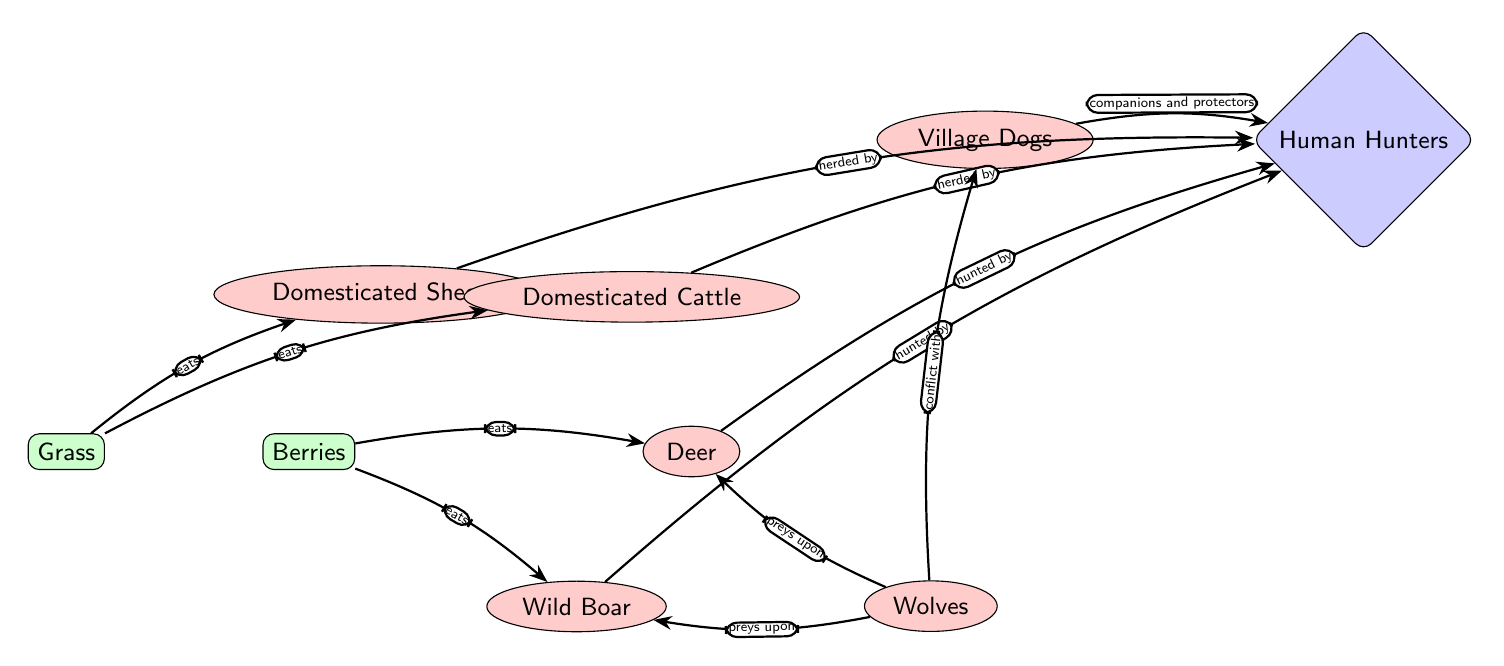What is the primary prey for domesticated sheep? The diagram indicates that domesticated sheep eat grass, as represented by the edge labeled "eats" from grass to sheep.
Answer: Grass How many types of predators are shown in the diagram? Counting the nodes labeled as predators, we find sheep, wild boar, domesticated cattle, deer, village dogs, and wolves. This totals six distinct predator types.
Answer: Six Which animal is primarily hunted by humans in the diagram? The diagram highlights deer and wild boar as prey hunted by humans, indicated by the edge labeled "hunted by" from deer and boar to humans.
Answer: Deer and wild boar What relationship do wolves have with deer according to the diagram? The edges labeled "preys upon" indicate that wolves prey on deer, showing a direct predator-prey relationship.
Answer: Preys upon Which domesticated animal is shown to be herded by humans? The diagram illustrates that both domesticated sheep and domesticated cattle are herded by humans, as indicated by the edges labeled "herded by."
Answer: Domesticated sheep and cattle How do dogs interact with humans in the ecosystem illustrated? The diagram indicates that dogs serve as companions and protectors for humans, marking their role in the human-animal relationship.
Answer: Companions and protectors What do wild boar primarily consume according to the food chain? The diagram shows an edge labeled "eats," pointing from berries to wild boar, indicating that wild boar primarily consume berries.
Answer: Berries What is the role of wolves in the ecosystem shown? The diagram shows that wolves are predators that prey upon both deer and wild boar, indicating their role as hunters within the food chain.
Answer: Predators How do the village dogs interact with wolves? The diagram shows an edge labeled "conflict with" indicating an adversarial relationship between village dogs and wolves, highlighting their competition in the ecosystem.
Answer: Conflict with 